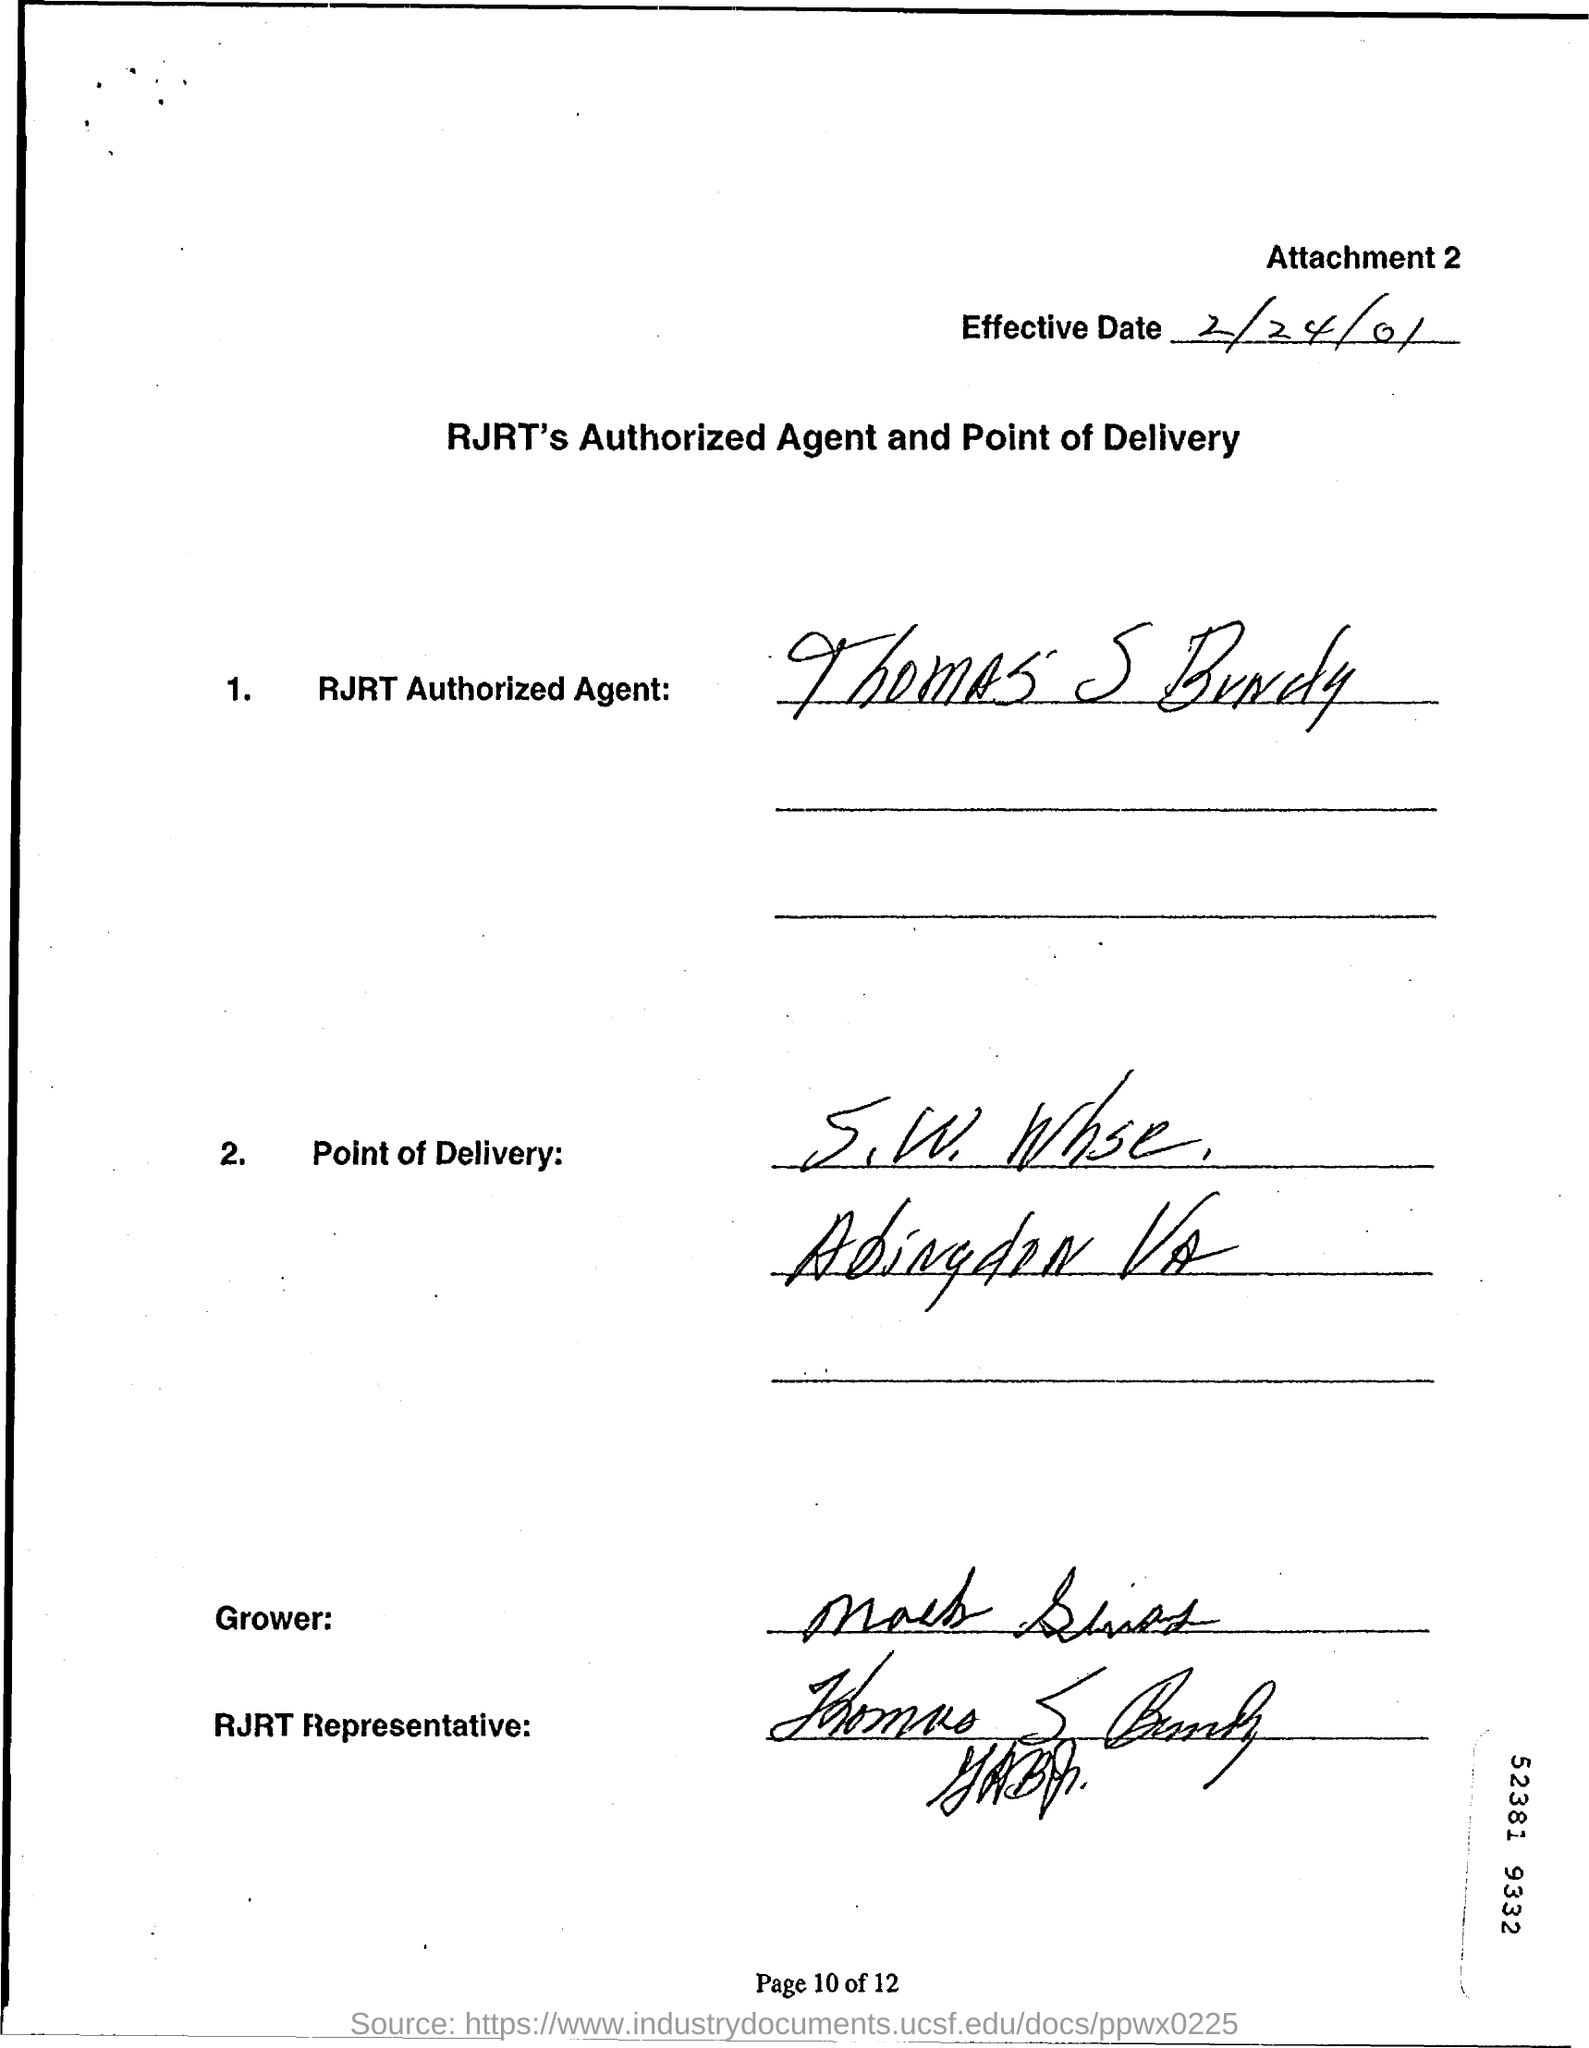What is the 'effective date' written in top of the document?
Offer a terse response. 2/24/01. Who is RJRT Authorized agent?
Provide a succinct answer. Thomas S Bundy. 